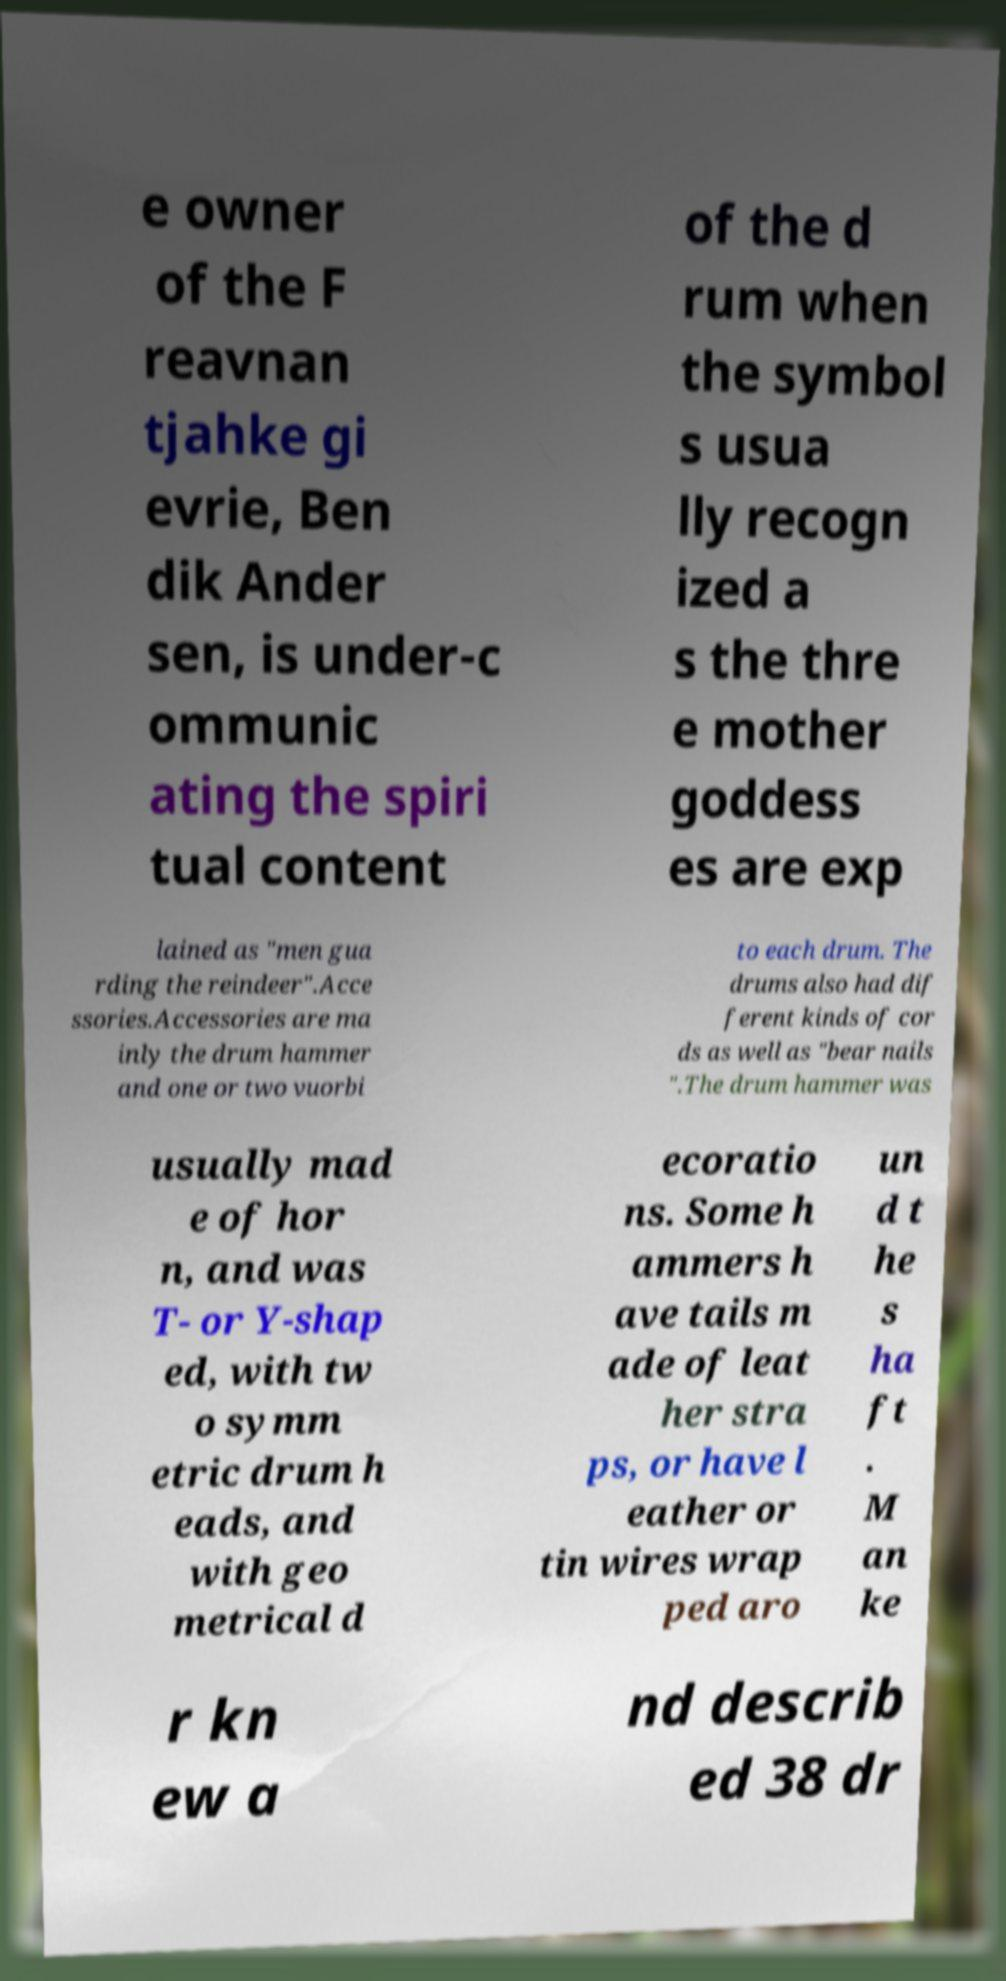For documentation purposes, I need the text within this image transcribed. Could you provide that? e owner of the F reavnan tjahke gi evrie, Ben dik Ander sen, is under-c ommunic ating the spiri tual content of the d rum when the symbol s usua lly recogn ized a s the thre e mother goddess es are exp lained as "men gua rding the reindeer".Acce ssories.Accessories are ma inly the drum hammer and one or two vuorbi to each drum. The drums also had dif ferent kinds of cor ds as well as "bear nails ".The drum hammer was usually mad e of hor n, and was T- or Y-shap ed, with tw o symm etric drum h eads, and with geo metrical d ecoratio ns. Some h ammers h ave tails m ade of leat her stra ps, or have l eather or tin wires wrap ped aro un d t he s ha ft . M an ke r kn ew a nd describ ed 38 dr 